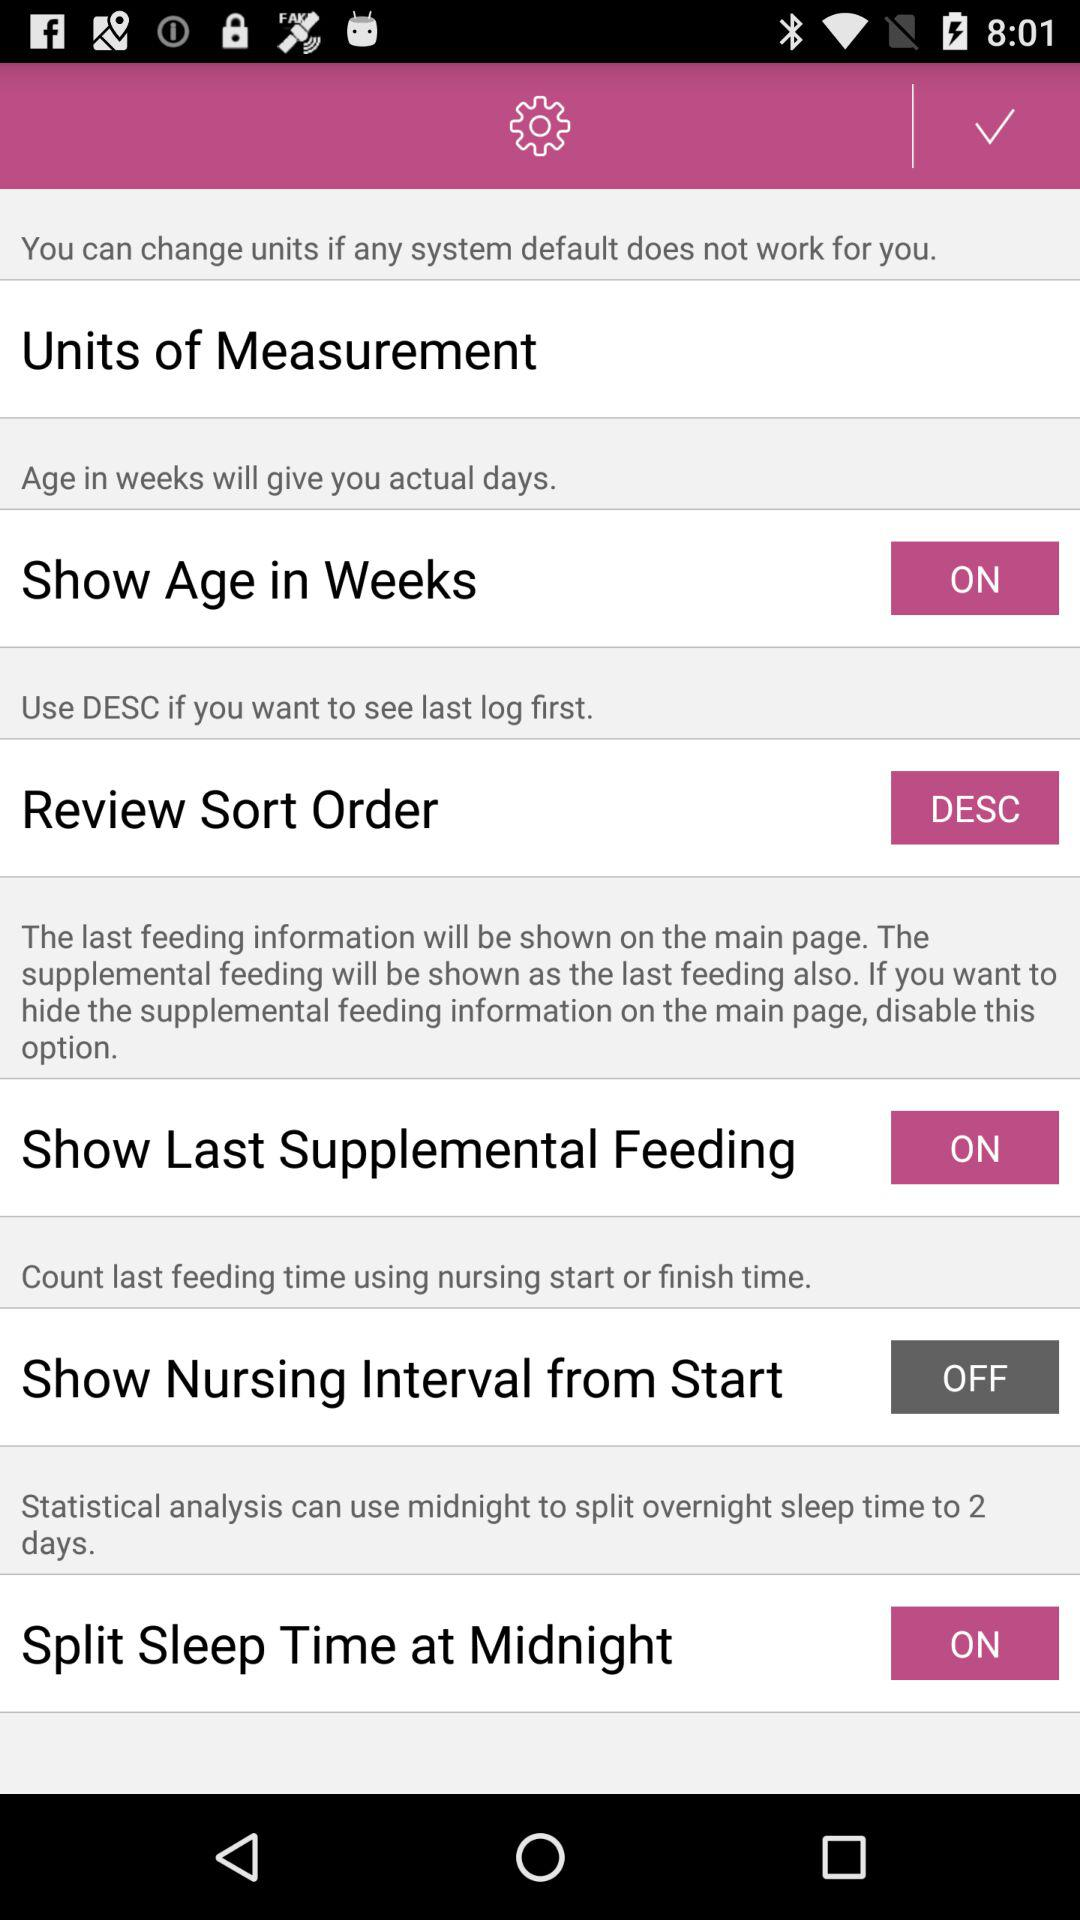Which sort option is selected for "Review Sort Order"? The selected sort option is "DESC". 